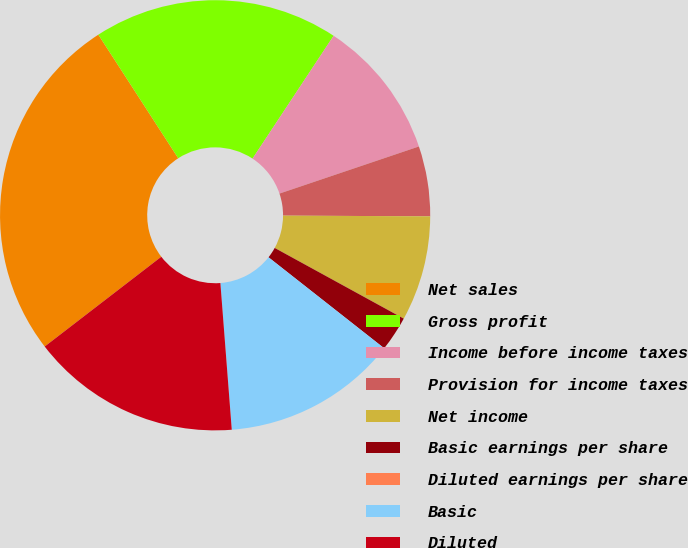Convert chart to OTSL. <chart><loc_0><loc_0><loc_500><loc_500><pie_chart><fcel>Net sales<fcel>Gross profit<fcel>Income before income taxes<fcel>Provision for income taxes<fcel>Net income<fcel>Basic earnings per share<fcel>Diluted earnings per share<fcel>Basic<fcel>Diluted<nl><fcel>26.31%<fcel>18.42%<fcel>10.53%<fcel>5.26%<fcel>7.9%<fcel>2.63%<fcel>0.0%<fcel>13.16%<fcel>15.79%<nl></chart> 